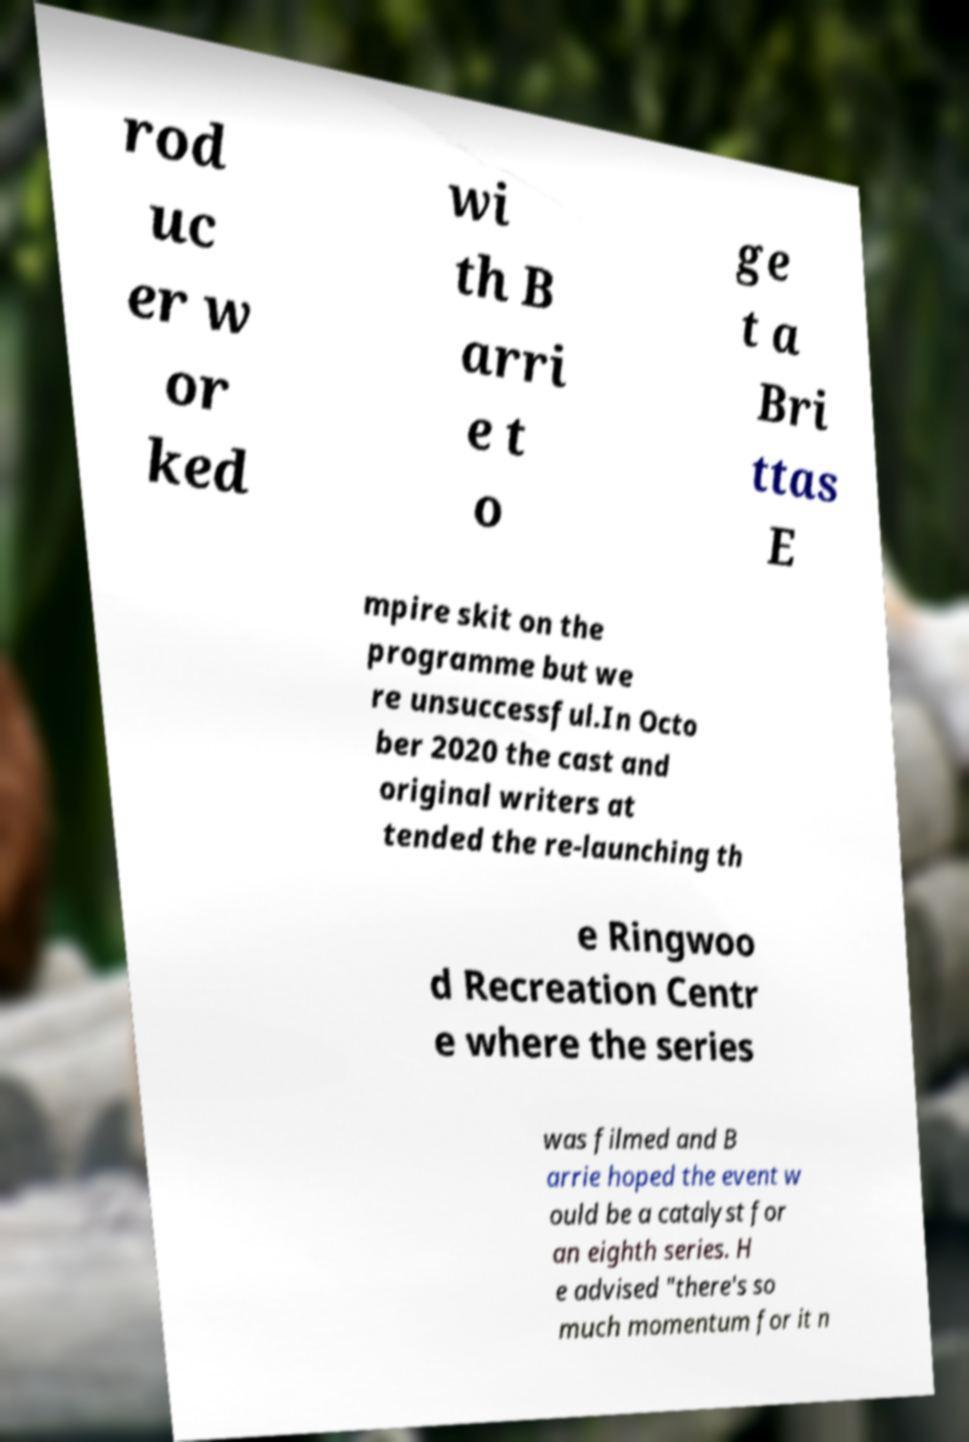Can you read and provide the text displayed in the image?This photo seems to have some interesting text. Can you extract and type it out for me? rod uc er w or ked wi th B arri e t o ge t a Bri ttas E mpire skit on the programme but we re unsuccessful.In Octo ber 2020 the cast and original writers at tended the re-launching th e Ringwoo d Recreation Centr e where the series was filmed and B arrie hoped the event w ould be a catalyst for an eighth series. H e advised "there's so much momentum for it n 